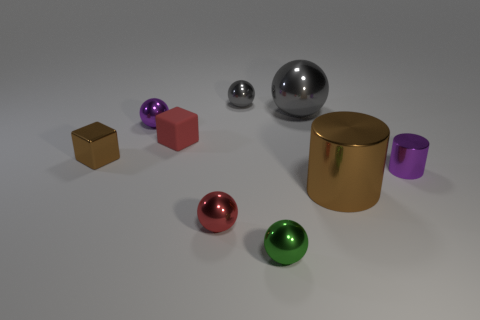What colors are represented in this collection of objects? The objects in the image feature a palette of colors including purple, red, green, silver, gold, and brown. These hues range from vibrant to muted, showcasing a contrast between the reflective spheres and the more subdued blocks. 